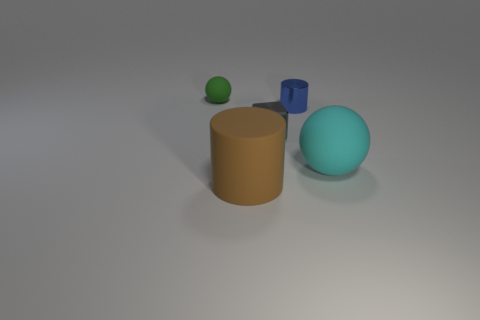Is the number of large cyan balls less than the number of big cyan matte cylinders?
Give a very brief answer. No. What color is the rubber thing that is both behind the brown thing and left of the big cyan ball?
Ensure brevity in your answer.  Green. There is a blue thing that is the same shape as the large brown rubber object; what is its material?
Your response must be concise. Metal. Is the number of large objects greater than the number of tiny green things?
Ensure brevity in your answer.  Yes. There is a rubber thing that is both on the left side of the blue object and on the right side of the tiny green ball; what size is it?
Give a very brief answer. Large. The gray metallic thing has what shape?
Ensure brevity in your answer.  Cube. How many small gray shiny objects have the same shape as the brown matte thing?
Offer a very short reply. 0. Is the number of large cyan balls that are to the left of the green rubber object less than the number of large matte things to the left of the large ball?
Offer a terse response. Yes. What number of cyan rubber balls are in front of the rubber thing to the right of the brown matte thing?
Your answer should be very brief. 0. Is there a red matte object?
Your response must be concise. No. 